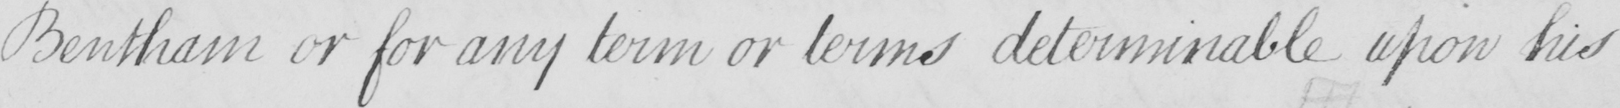Please provide the text content of this handwritten line. Bentham or for any term or terms determinable upon his 